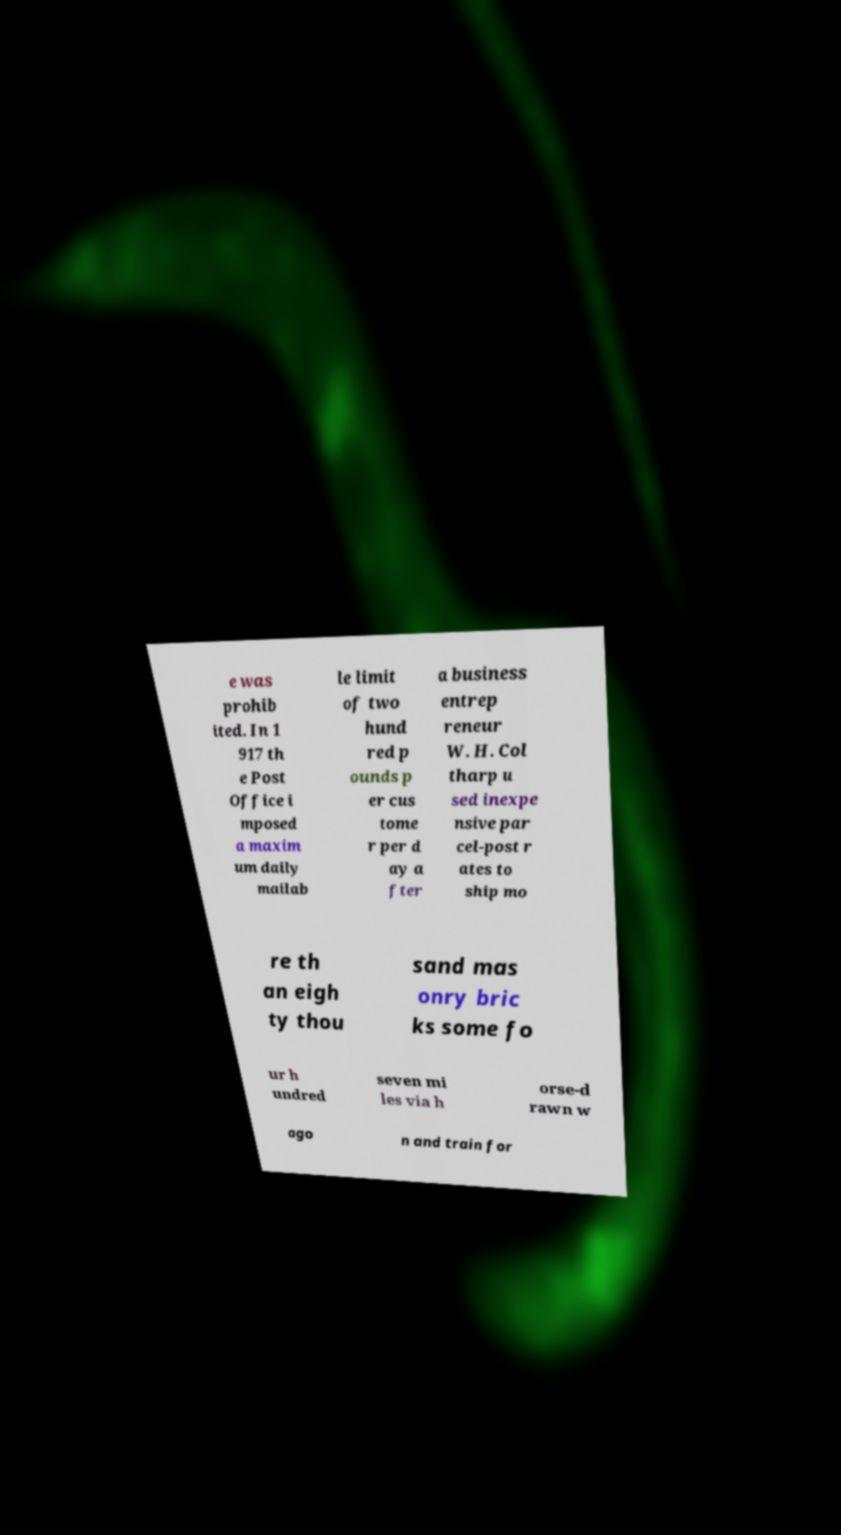Could you extract and type out the text from this image? e was prohib ited. In 1 917 th e Post Office i mposed a maxim um daily mailab le limit of two hund red p ounds p er cus tome r per d ay a fter a business entrep reneur W. H. Col tharp u sed inexpe nsive par cel-post r ates to ship mo re th an eigh ty thou sand mas onry bric ks some fo ur h undred seven mi les via h orse-d rawn w ago n and train for 